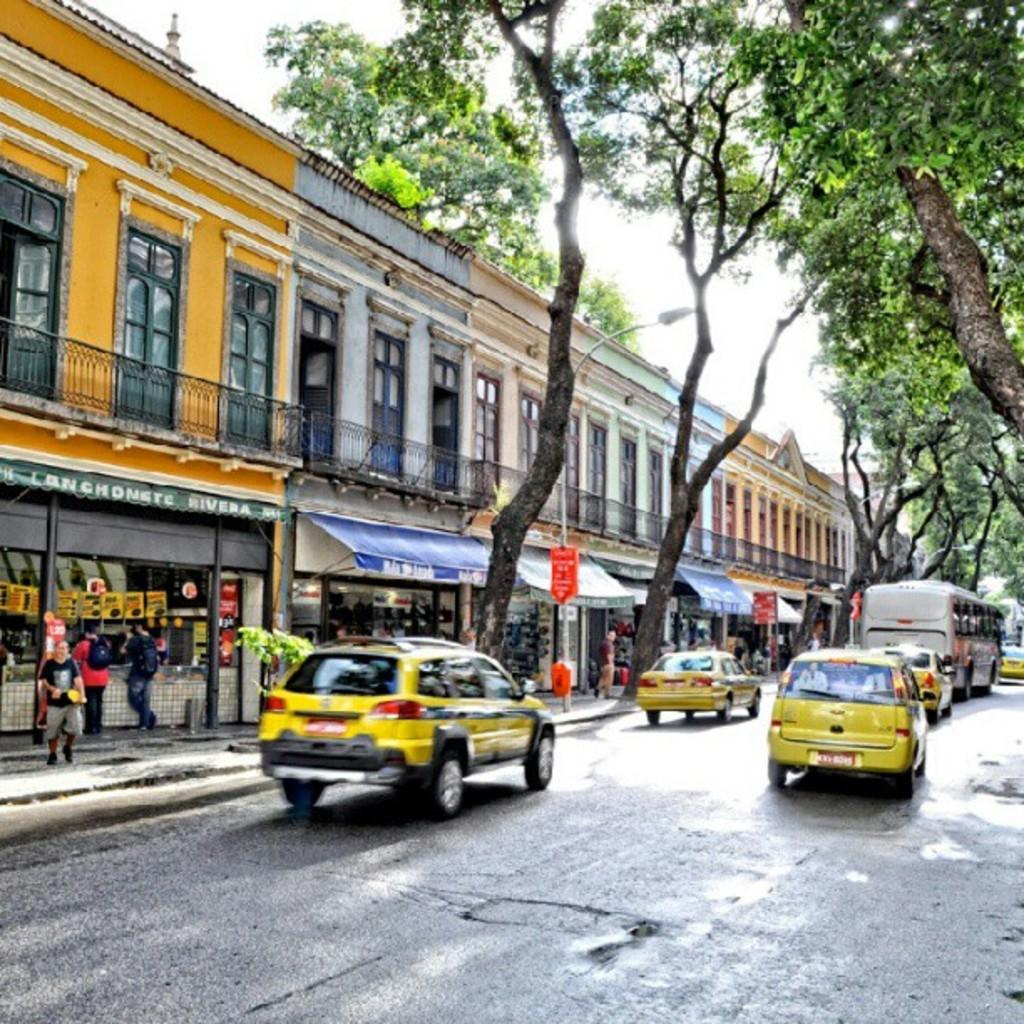<image>
Provide a brief description of the given image. Street shops including the one with a green banner saying "rivera" are shown with yellow cabs driving by. 